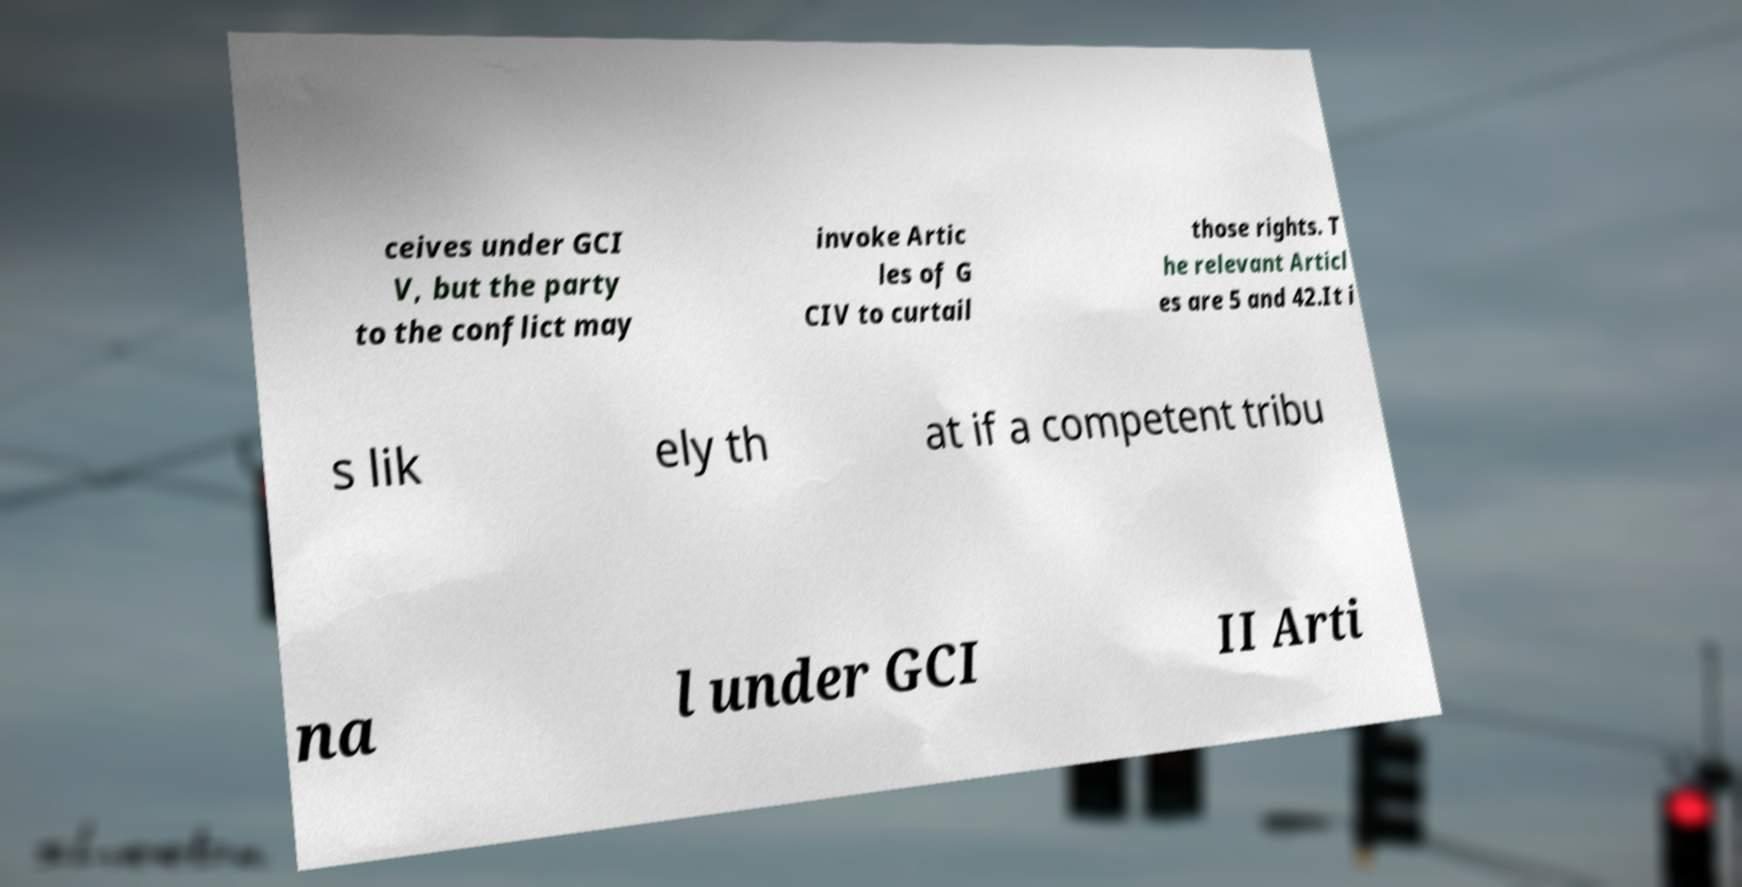Could you assist in decoding the text presented in this image and type it out clearly? ceives under GCI V, but the party to the conflict may invoke Artic les of G CIV to curtail those rights. T he relevant Articl es are 5 and 42.It i s lik ely th at if a competent tribu na l under GCI II Arti 